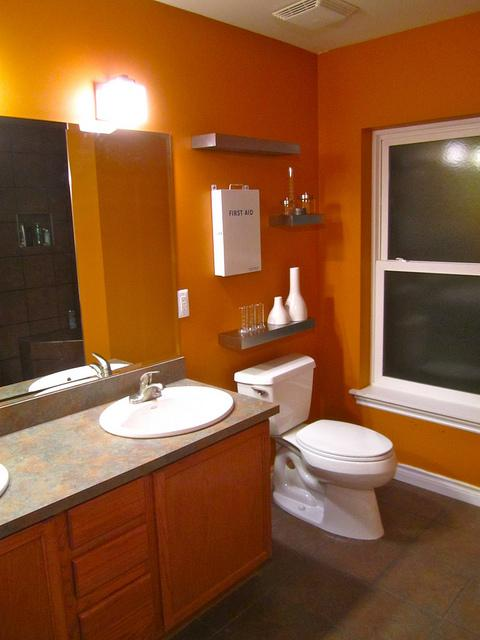What color is the writing on front of the first aid case on the wall?

Choices:
A) yellow
B) red
C) black
D) blue black 